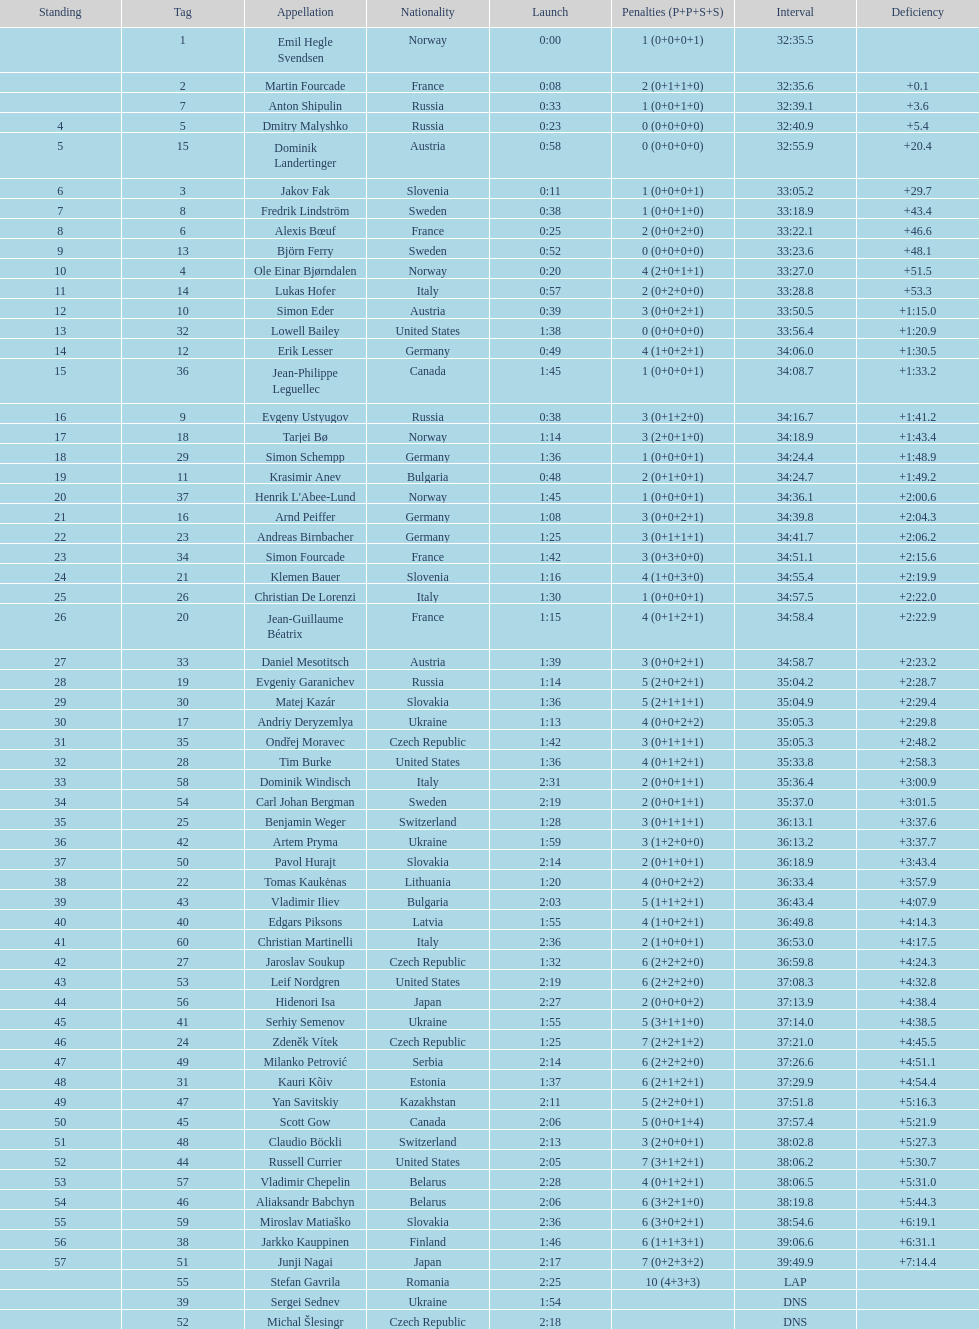What is the total number of participants between norway and france? 7. 